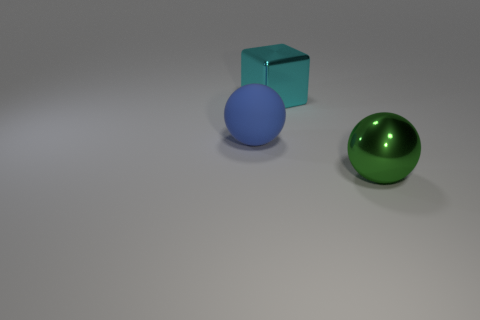Add 3 tiny yellow matte spheres. How many objects exist? 6 Add 2 small red rubber balls. How many small red rubber balls exist? 2 Subtract all blue spheres. How many spheres are left? 1 Subtract 0 red cylinders. How many objects are left? 3 Subtract all blocks. How many objects are left? 2 Subtract 1 balls. How many balls are left? 1 Subtract all blue spheres. Subtract all blue cubes. How many spheres are left? 1 Subtract all gray cubes. How many green spheres are left? 1 Subtract all blocks. Subtract all small gray shiny cylinders. How many objects are left? 2 Add 3 large cyan metal things. How many large cyan metal things are left? 4 